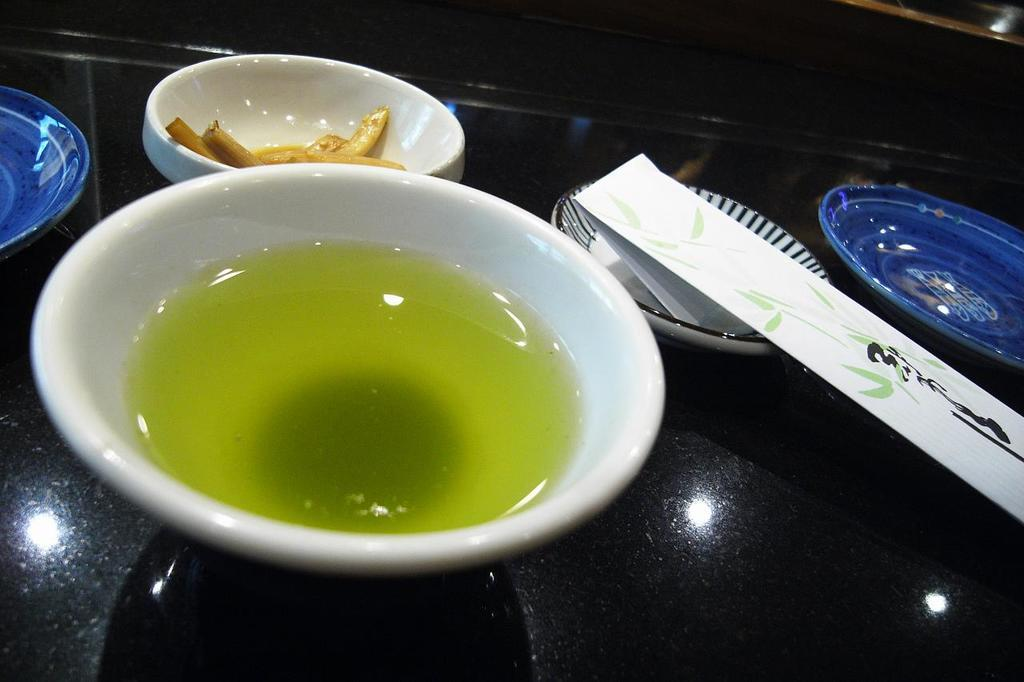What is the primary object in the image? There is a black tray in the image. What is placed on the tray? There are plates and a bowl on the tray. What is in the bowl? The bowl contains soup. What else can be seen on the plates? There are food items on the plates. What additional object is present on the tray? There is an object on the tray. Is there a river flowing through the canvas in the image? There is no canvas or river present in the image. 